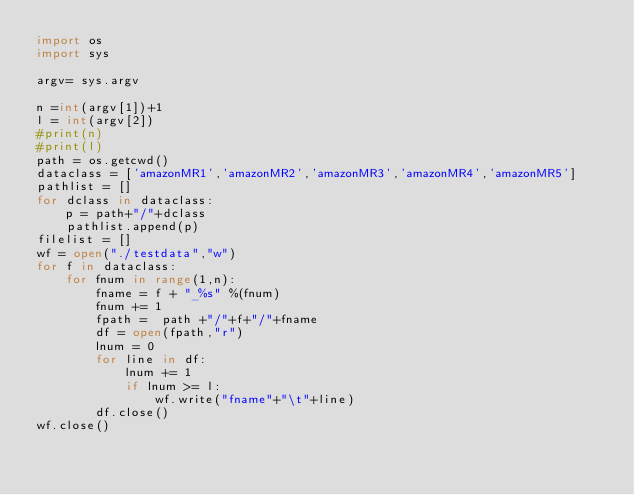<code> <loc_0><loc_0><loc_500><loc_500><_Python_>import os
import sys

argv= sys.argv

n =int(argv[1])+1
l = int(argv[2])
#print(n)
#print(l)
path = os.getcwd()
dataclass = ['amazonMR1','amazonMR2','amazonMR3','amazonMR4','amazonMR5']
pathlist = []
for dclass in dataclass:
    p = path+"/"+dclass
    pathlist.append(p)
filelist = []
wf = open("./testdata","w")
for f in dataclass:
    for fnum in range(1,n):
        fname = f + "_%s" %(fnum)
        fnum += 1
        fpath =  path +"/"+f+"/"+fname
        df = open(fpath,"r")
        lnum = 0
        for line in df:
            lnum += 1
            if lnum >= l:
                wf.write("fname"+"\t"+line)
        df.close()
wf.close()
    
</code> 